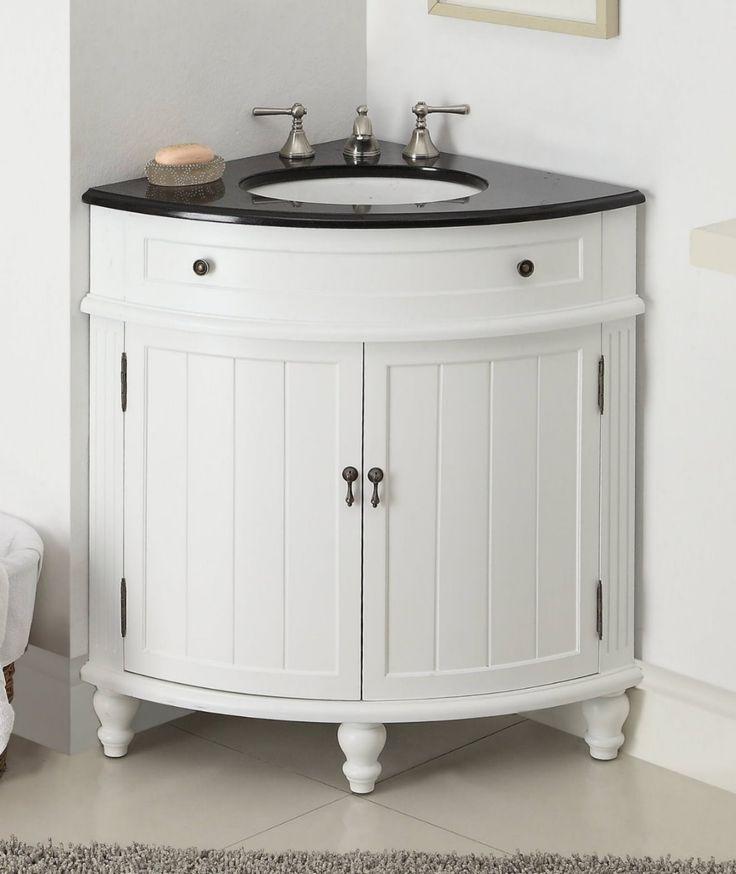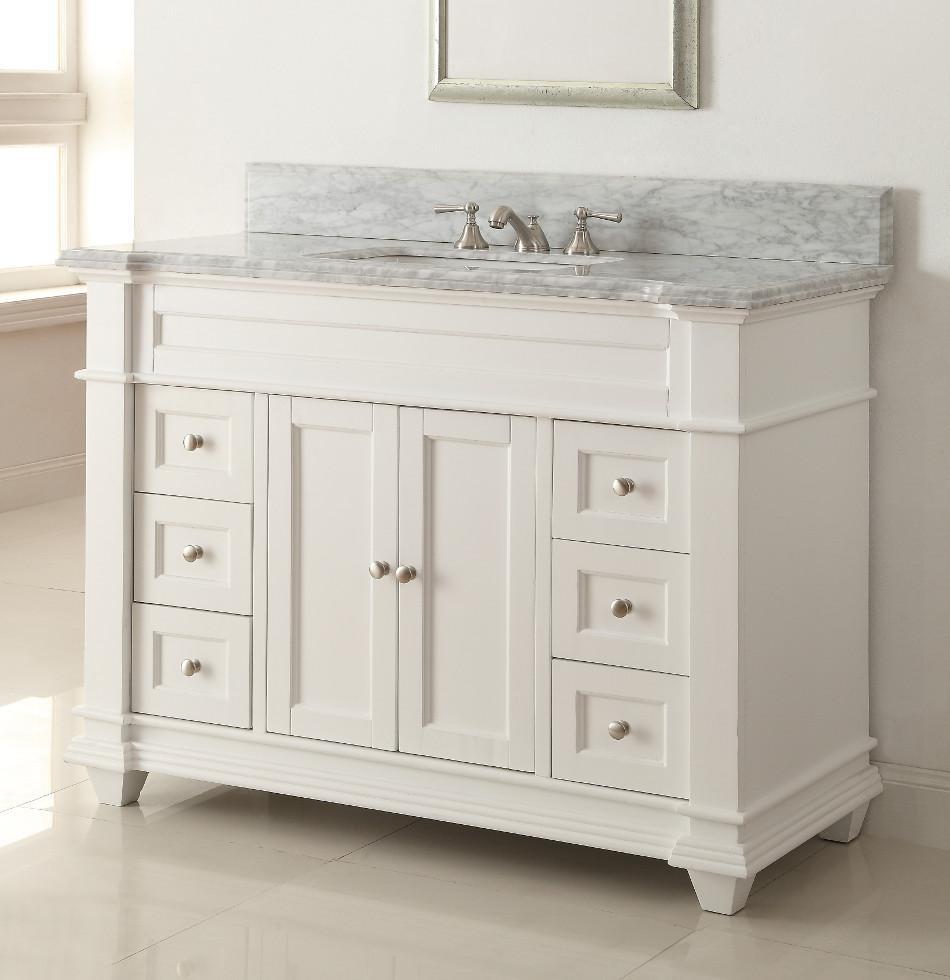The first image is the image on the left, the second image is the image on the right. Given the left and right images, does the statement "Both sink cabinets are corner units." hold true? Answer yes or no. No. The first image is the image on the left, the second image is the image on the right. For the images shown, is this caption "One image shows a corner vanity with a white cabinet and an inset sink instead of a vessel sink." true? Answer yes or no. Yes. 